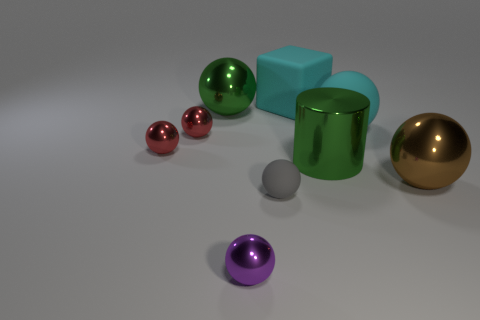Subtract all purple metal balls. How many balls are left? 6 Subtract all brown cylinders. How many red spheres are left? 2 Subtract 5 balls. How many balls are left? 2 Subtract all spheres. How many objects are left? 2 Add 2 small gray spheres. How many small gray spheres are left? 3 Add 3 big green spheres. How many big green spheres exist? 4 Subtract all red spheres. How many spheres are left? 5 Subtract 1 brown balls. How many objects are left? 8 Subtract all brown blocks. Subtract all yellow spheres. How many blocks are left? 1 Subtract all big cylinders. Subtract all cyan rubber blocks. How many objects are left? 7 